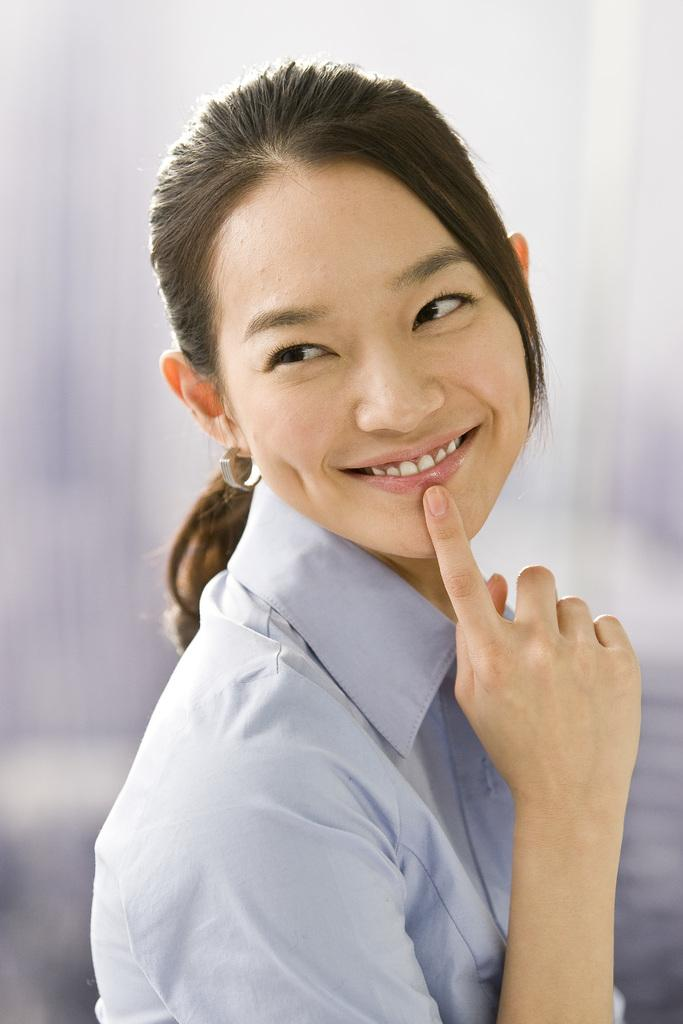What is the main subject of the image? There is a person in the image. How does the person appear to be feeling? The person has a smiling face, suggesting they are happy or content. Can you describe the background of the image? The background appears blurry, which may indicate that the person is the primary focus of the image. What type of list can be seen on the playground in the image? There is no list or playground present in the image; it features a person with a smiling face and a blurry background. How many bags of popcorn are visible on the person's lap in the image? There are no bags of popcorn present in the image. 